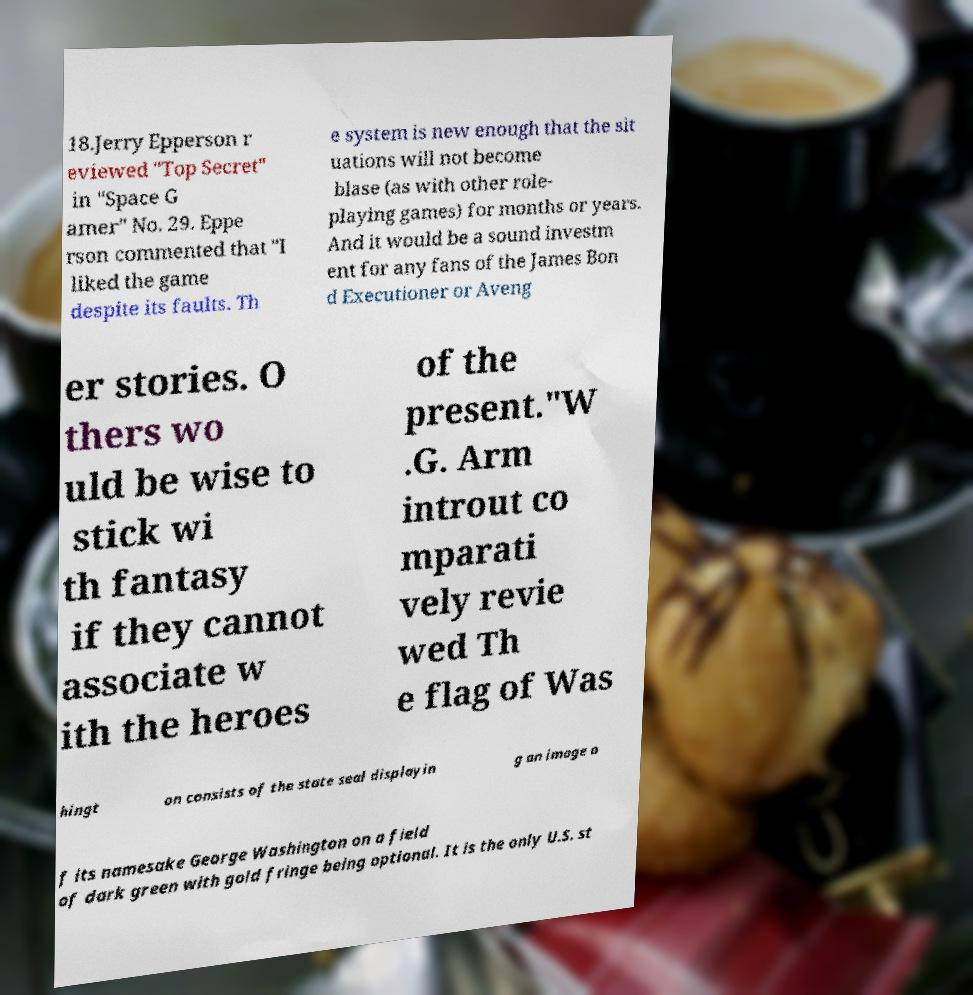Please identify and transcribe the text found in this image. 18.Jerry Epperson r eviewed "Top Secret" in "Space G amer" No. 29. Eppe rson commented that "I liked the game despite its faults. Th e system is new enough that the sit uations will not become blase (as with other role- playing games) for months or years. And it would be a sound investm ent for any fans of the James Bon d Executioner or Aveng er stories. O thers wo uld be wise to stick wi th fantasy if they cannot associate w ith the heroes of the present."W .G. Arm introut co mparati vely revie wed Th e flag of Was hingt on consists of the state seal displayin g an image o f its namesake George Washington on a field of dark green with gold fringe being optional. It is the only U.S. st 